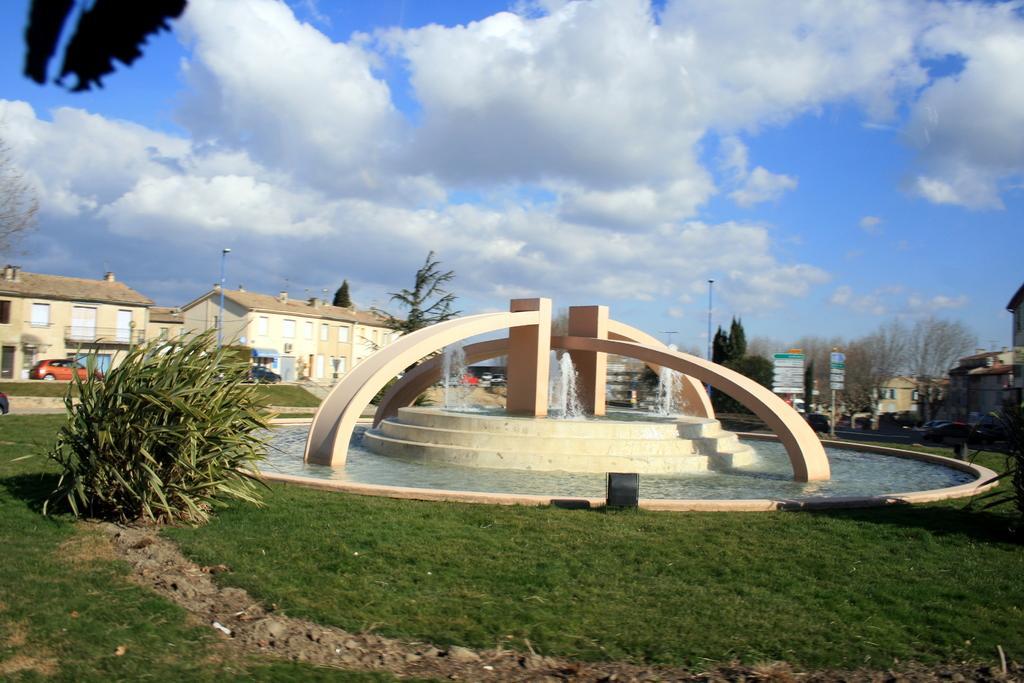Please provide a concise description of this image. As we can see in the image there is grass, plant, trees, water, buildings, sky and clouds. 